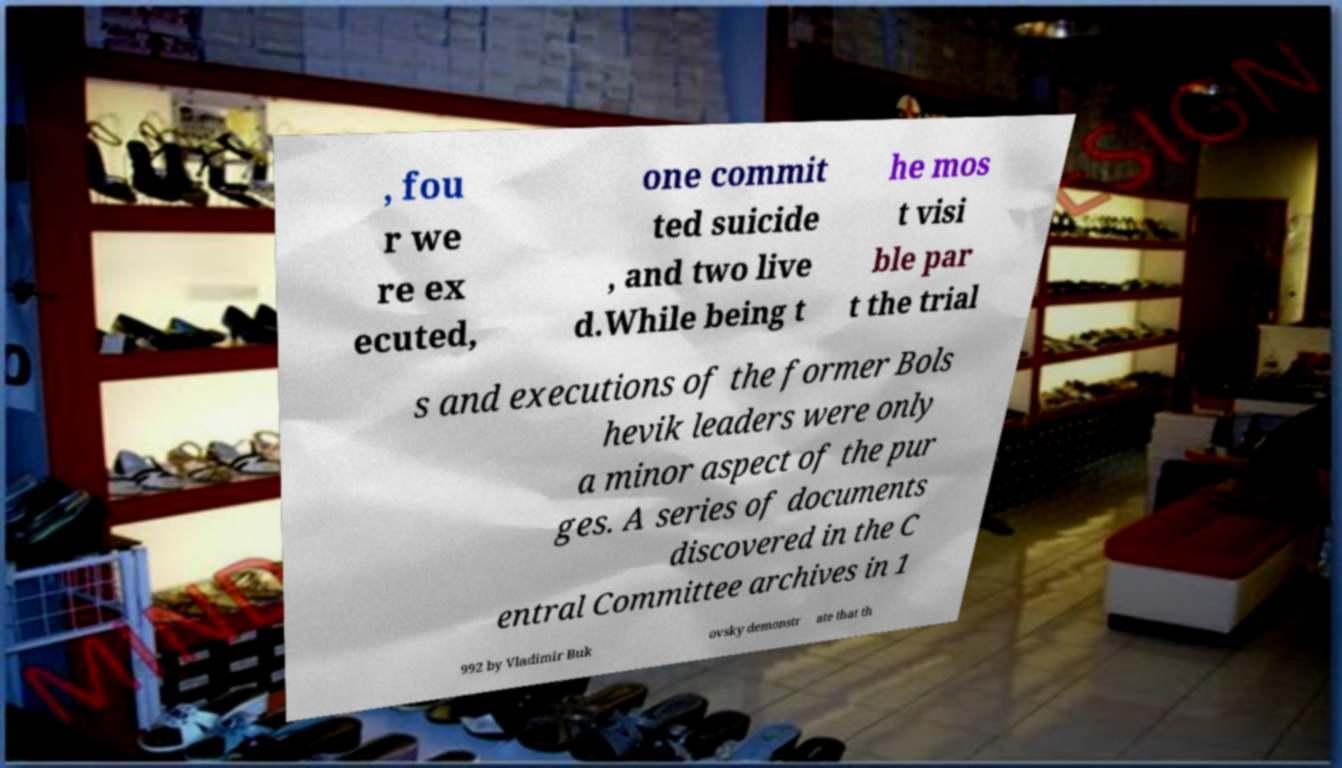There's text embedded in this image that I need extracted. Can you transcribe it verbatim? , fou r we re ex ecuted, one commit ted suicide , and two live d.While being t he mos t visi ble par t the trial s and executions of the former Bols hevik leaders were only a minor aspect of the pur ges. A series of documents discovered in the C entral Committee archives in 1 992 by Vladimir Buk ovsky demonstr ate that th 